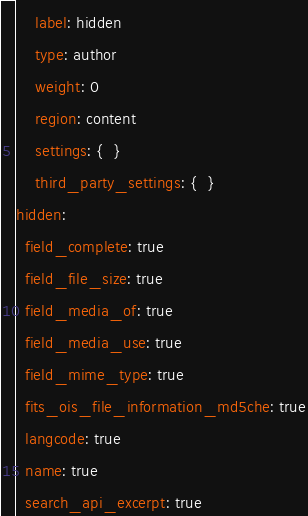Convert code to text. <code><loc_0><loc_0><loc_500><loc_500><_YAML_>    label: hidden
    type: author
    weight: 0
    region: content
    settings: {  }
    third_party_settings: {  }
hidden:
  field_complete: true
  field_file_size: true
  field_media_of: true
  field_media_use: true
  field_mime_type: true
  fits_ois_file_information_md5che: true
  langcode: true
  name: true
  search_api_excerpt: true
</code> 